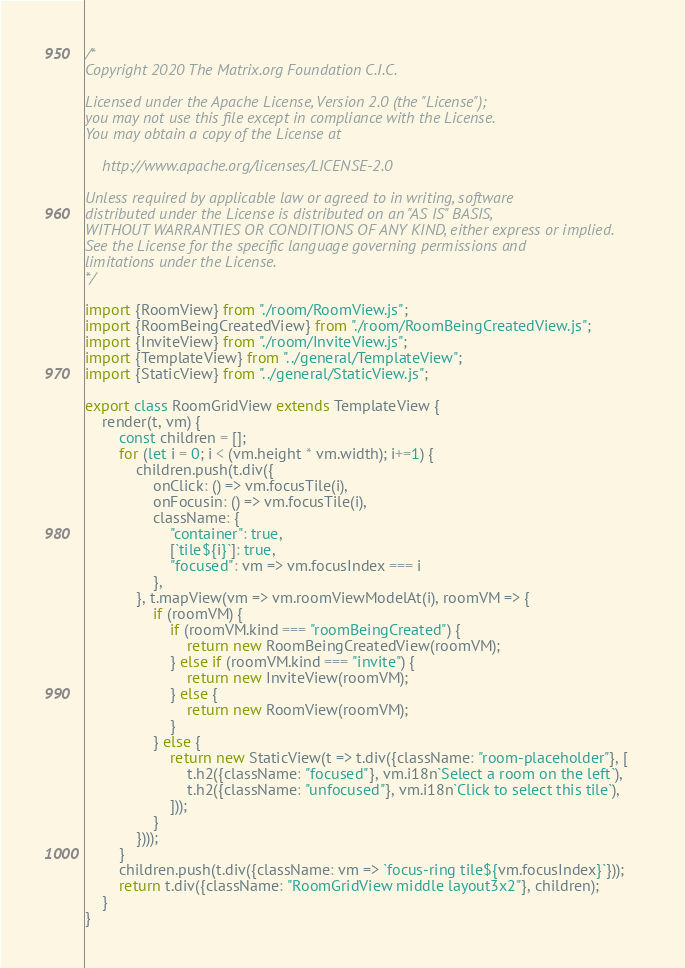<code> <loc_0><loc_0><loc_500><loc_500><_JavaScript_>/*
Copyright 2020 The Matrix.org Foundation C.I.C.

Licensed under the Apache License, Version 2.0 (the "License");
you may not use this file except in compliance with the License.
You may obtain a copy of the License at

    http://www.apache.org/licenses/LICENSE-2.0

Unless required by applicable law or agreed to in writing, software
distributed under the License is distributed on an "AS IS" BASIS,
WITHOUT WARRANTIES OR CONDITIONS OF ANY KIND, either express or implied.
See the License for the specific language governing permissions and
limitations under the License.
*/

import {RoomView} from "./room/RoomView.js";
import {RoomBeingCreatedView} from "./room/RoomBeingCreatedView.js";
import {InviteView} from "./room/InviteView.js";
import {TemplateView} from "../general/TemplateView";
import {StaticView} from "../general/StaticView.js";

export class RoomGridView extends TemplateView {
    render(t, vm) {
        const children = [];
        for (let i = 0; i < (vm.height * vm.width); i+=1) {
            children.push(t.div({
                onClick: () => vm.focusTile(i),
                onFocusin: () => vm.focusTile(i),
                className: {
                    "container": true,
                    [`tile${i}`]: true,
                    "focused": vm => vm.focusIndex === i
                },
            }, t.mapView(vm => vm.roomViewModelAt(i), roomVM => {
                if (roomVM) {
                    if (roomVM.kind === "roomBeingCreated") {
                        return new RoomBeingCreatedView(roomVM);
                    } else if (roomVM.kind === "invite") {
                        return new InviteView(roomVM);
                    } else {
                        return new RoomView(roomVM);
                    }
                } else {
                    return new StaticView(t => t.div({className: "room-placeholder"}, [
                        t.h2({className: "focused"}, vm.i18n`Select a room on the left`),
                        t.h2({className: "unfocused"}, vm.i18n`Click to select this tile`),
                    ]));
                }
            })));
        }
        children.push(t.div({className: vm => `focus-ring tile${vm.focusIndex}`}));
        return t.div({className: "RoomGridView middle layout3x2"}, children);
    }
}
</code> 